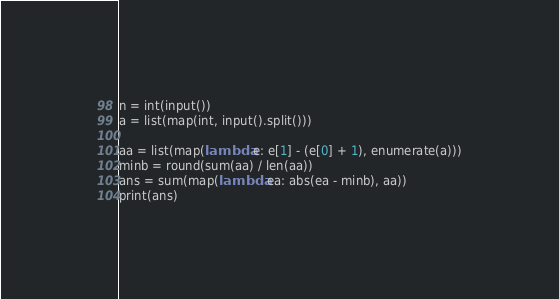<code> <loc_0><loc_0><loc_500><loc_500><_Python_>n = int(input())
a = list(map(int, input().split()))

aa = list(map(lambda e: e[1] - (e[0] + 1), enumerate(a)))
minb = round(sum(aa) / len(aa))
ans = sum(map(lambda ea: abs(ea - minb), aa))
print(ans)</code> 